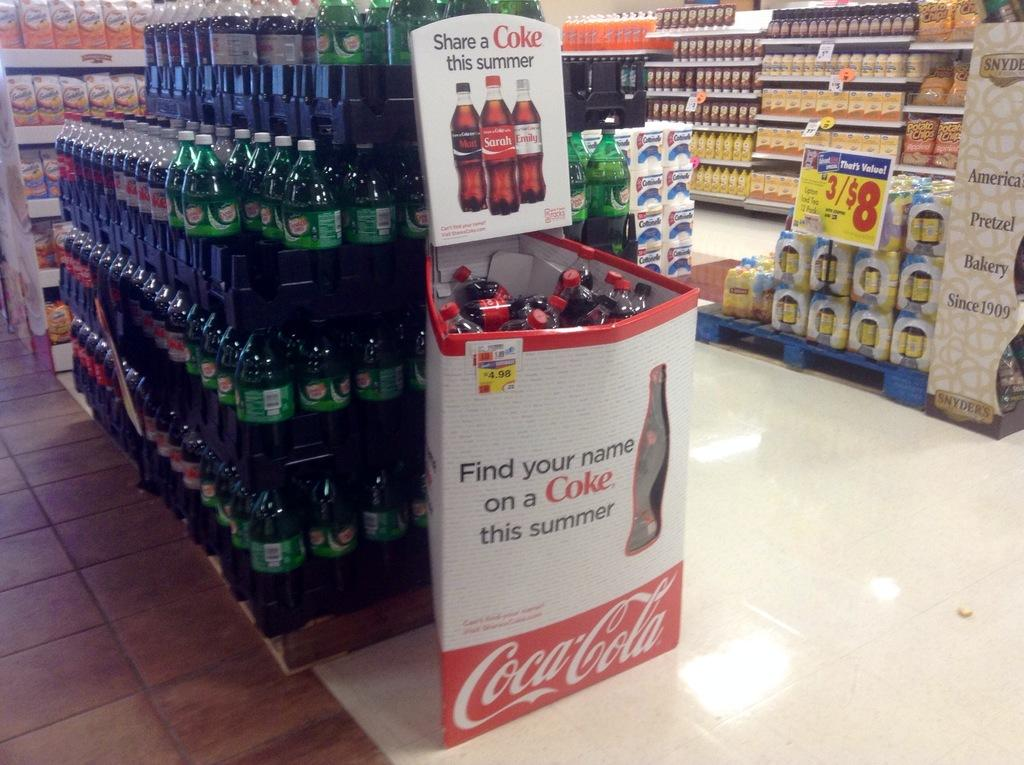<image>
Offer a succinct explanation of the picture presented. A display of Coca Cola products in a grocery store. 